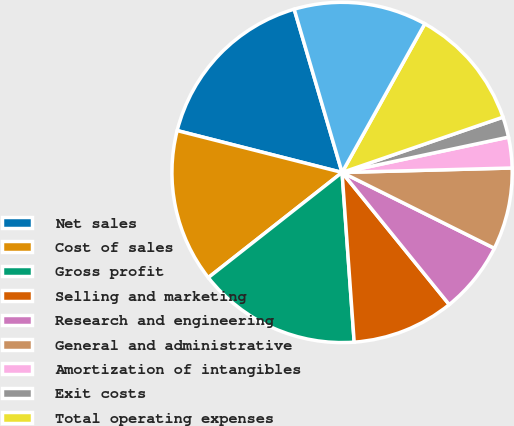Convert chart. <chart><loc_0><loc_0><loc_500><loc_500><pie_chart><fcel>Net sales<fcel>Cost of sales<fcel>Gross profit<fcel>Selling and marketing<fcel>Research and engineering<fcel>General and administrative<fcel>Amortization of intangibles<fcel>Exit costs<fcel>Total operating expenses<fcel>Operating income<nl><fcel>16.5%<fcel>14.56%<fcel>15.53%<fcel>9.71%<fcel>6.8%<fcel>7.77%<fcel>2.91%<fcel>1.94%<fcel>11.65%<fcel>12.62%<nl></chart> 